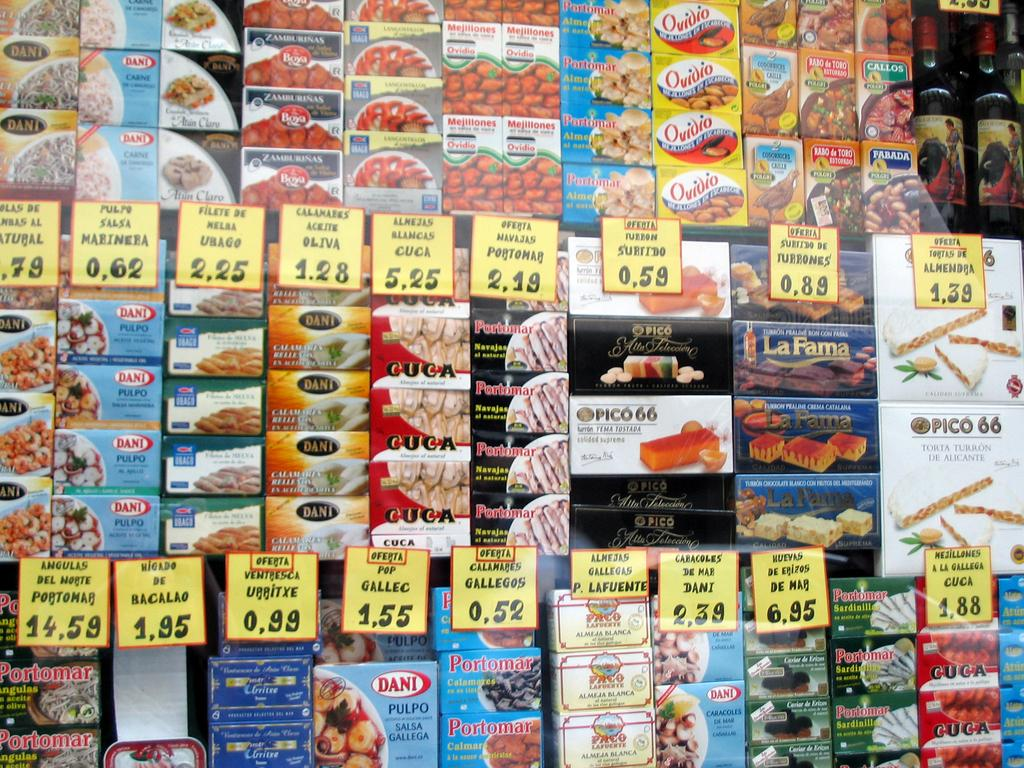<image>
Relay a brief, clear account of the picture shown. Bunch of products on a shelf in store and one of the products is Dani. 